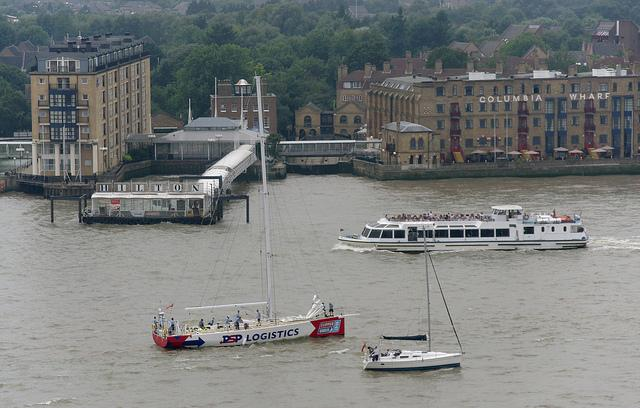In what country is this river in?

Choices:
A) italy
B) britain
C) france
D) spain britain 